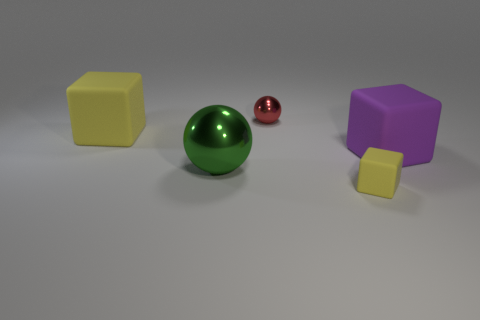What might the arrangement of these objects signify? The arrangement of these objects - two cubes, one large green sphere, and a smaller red sphere - could signify a study in geometry and color contrast. Their distribution in space suggests a deliberate choice to highlight the differences in shape and size as well as the interaction between matte and reflective surfaces. 